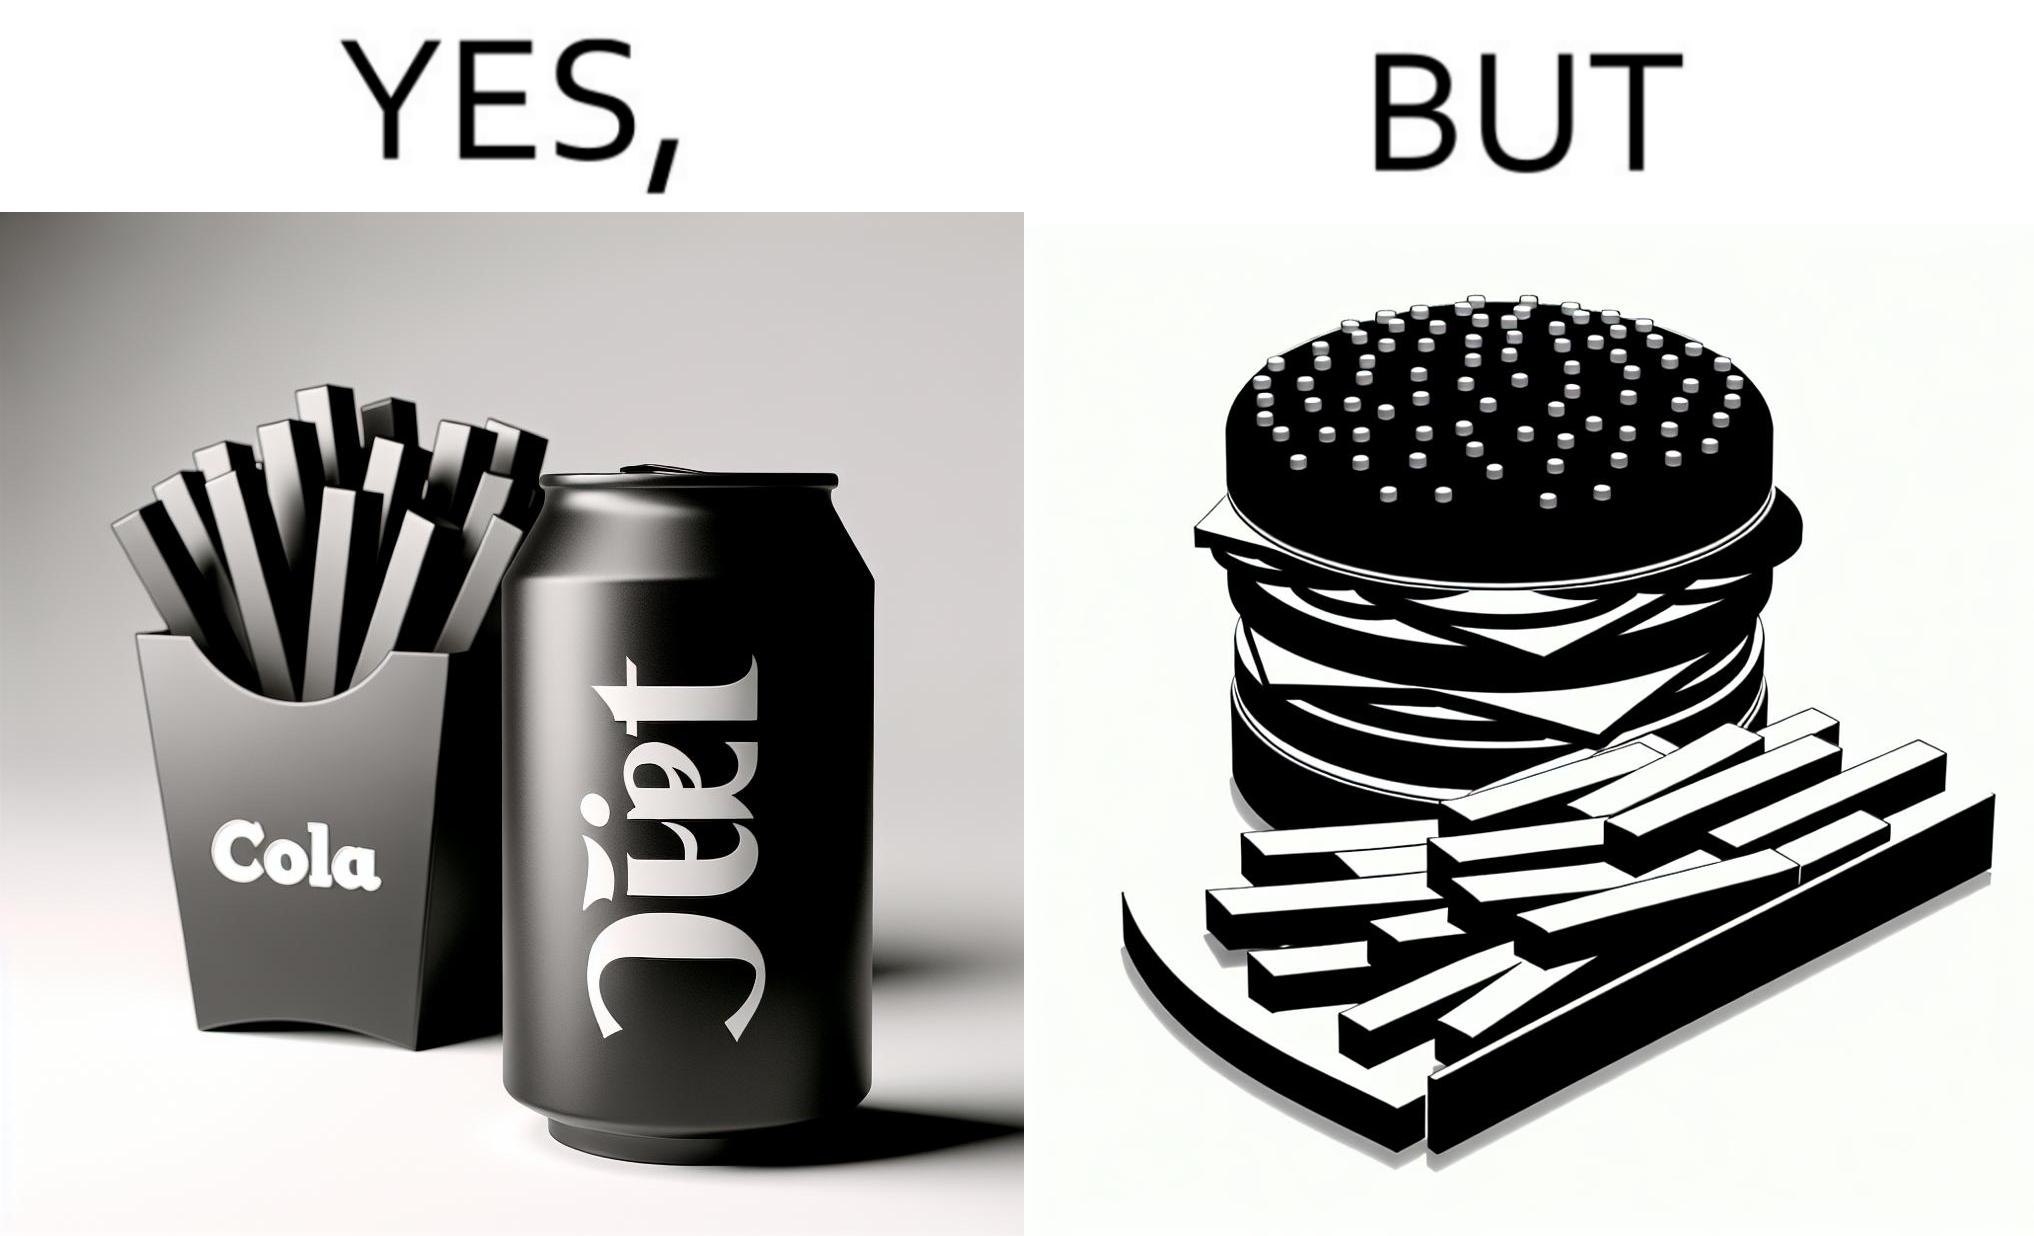Is there satirical content in this image? Yes, this image is satirical. 